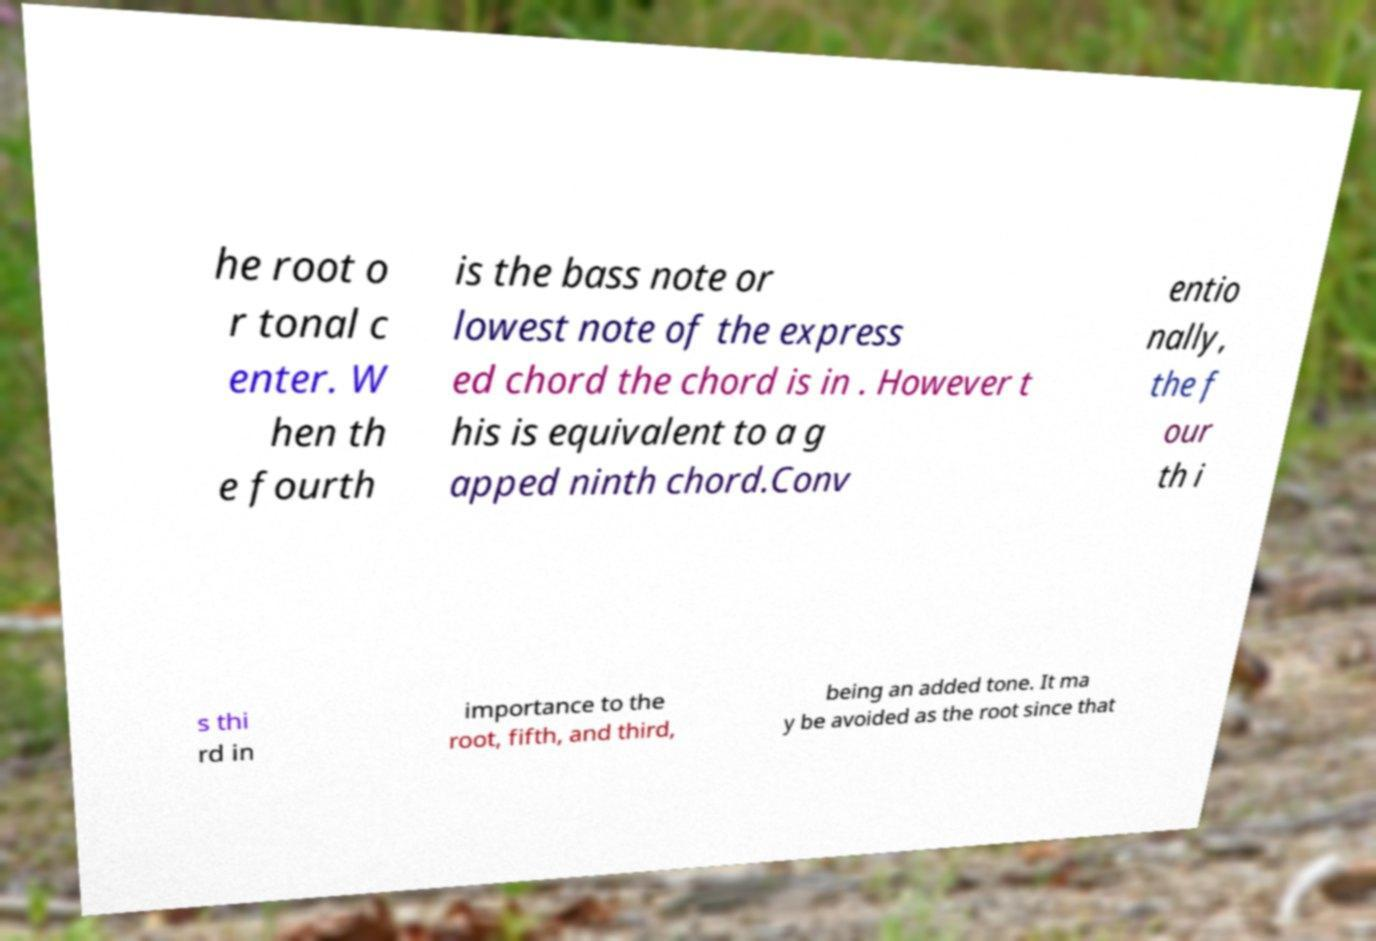Could you extract and type out the text from this image? he root o r tonal c enter. W hen th e fourth is the bass note or lowest note of the express ed chord the chord is in . However t his is equivalent to a g apped ninth chord.Conv entio nally, the f our th i s thi rd in importance to the root, fifth, and third, being an added tone. It ma y be avoided as the root since that 